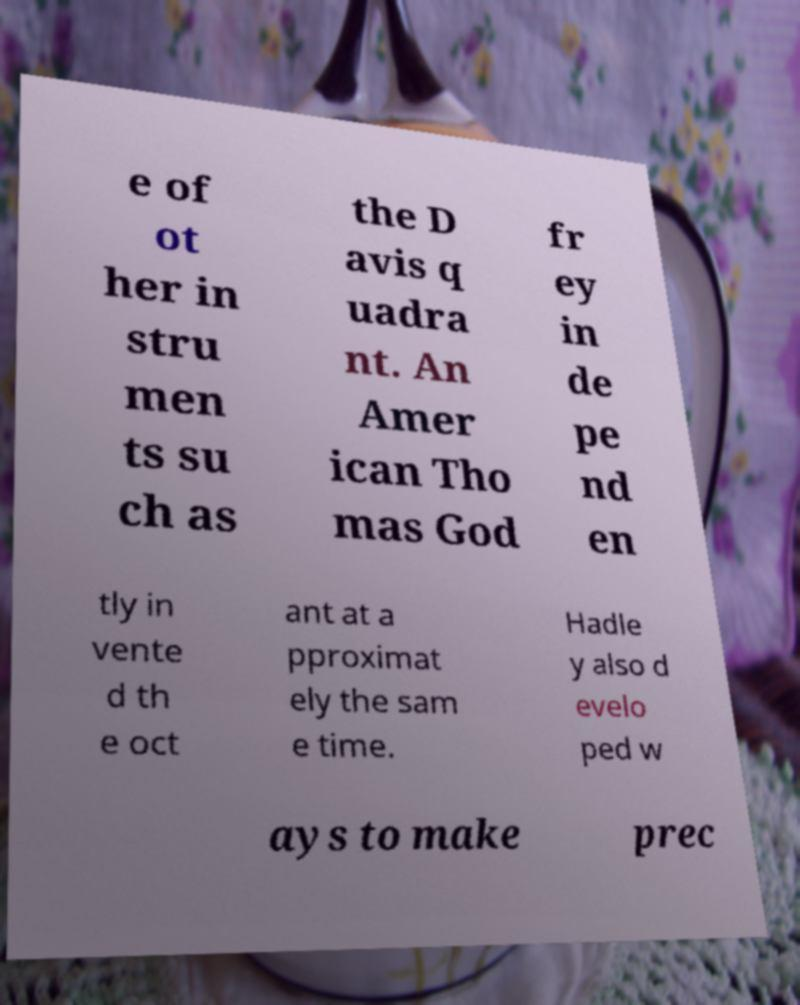There's text embedded in this image that I need extracted. Can you transcribe it verbatim? e of ot her in stru men ts su ch as the D avis q uadra nt. An Amer ican Tho mas God fr ey in de pe nd en tly in vente d th e oct ant at a pproximat ely the sam e time. Hadle y also d evelo ped w ays to make prec 